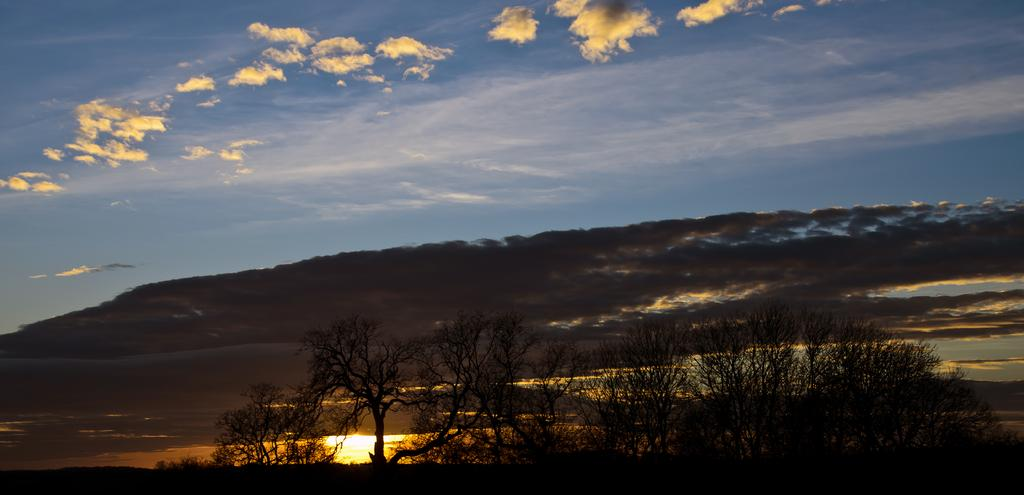What type of vegetation can be seen in the image? There are trees in the image. What part of the natural environment is visible in the image? The sky is visible in the background of the image. What type of drink is being served under the veil in the image? There is no drink or veil present in the image; it only features trees and the sky. 